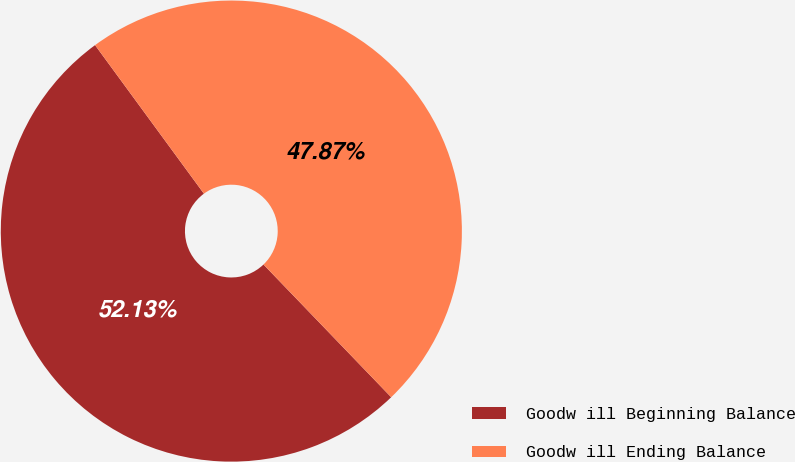<chart> <loc_0><loc_0><loc_500><loc_500><pie_chart><fcel>Goodw ill Beginning Balance<fcel>Goodw ill Ending Balance<nl><fcel>52.13%<fcel>47.87%<nl></chart> 